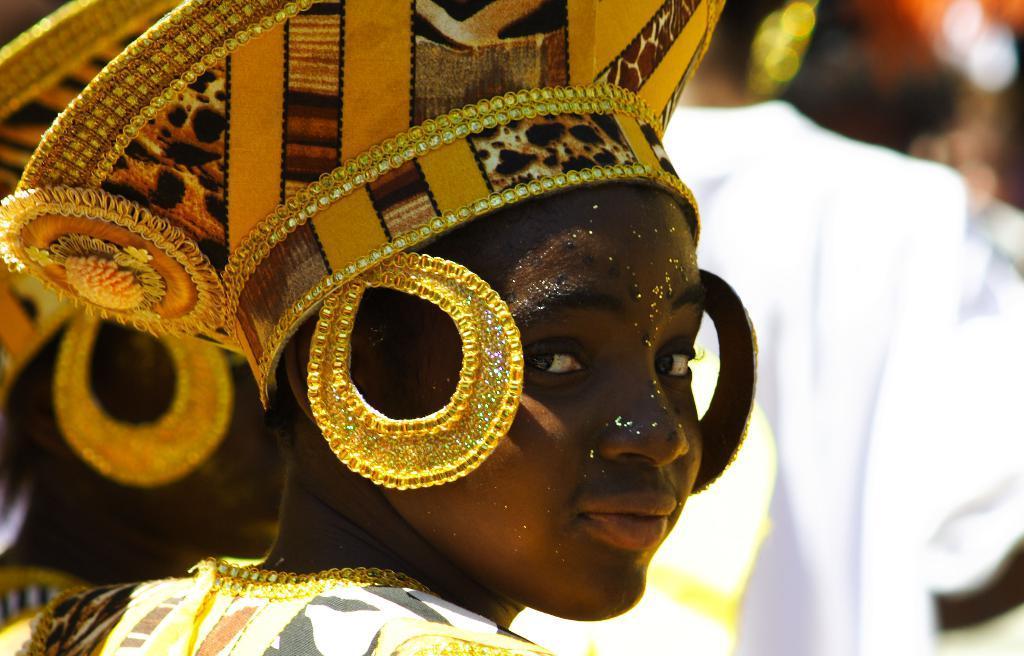How would you summarize this image in a sentence or two? In the center of the image we can see one person with a different costume. In the background, we can see it is blurred. 